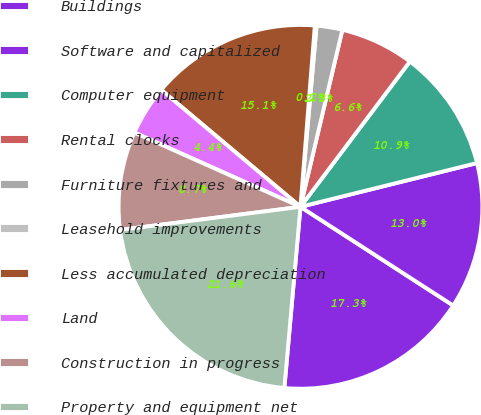Convert chart. <chart><loc_0><loc_0><loc_500><loc_500><pie_chart><fcel>Buildings<fcel>Software and capitalized<fcel>Computer equipment<fcel>Rental clocks<fcel>Furniture fixtures and<fcel>Leasehold improvements<fcel>Less accumulated depreciation<fcel>Land<fcel>Construction in progress<fcel>Property and equipment net<nl><fcel>17.28%<fcel>13.0%<fcel>10.86%<fcel>6.57%<fcel>2.29%<fcel>0.15%<fcel>15.14%<fcel>4.43%<fcel>8.72%<fcel>21.56%<nl></chart> 